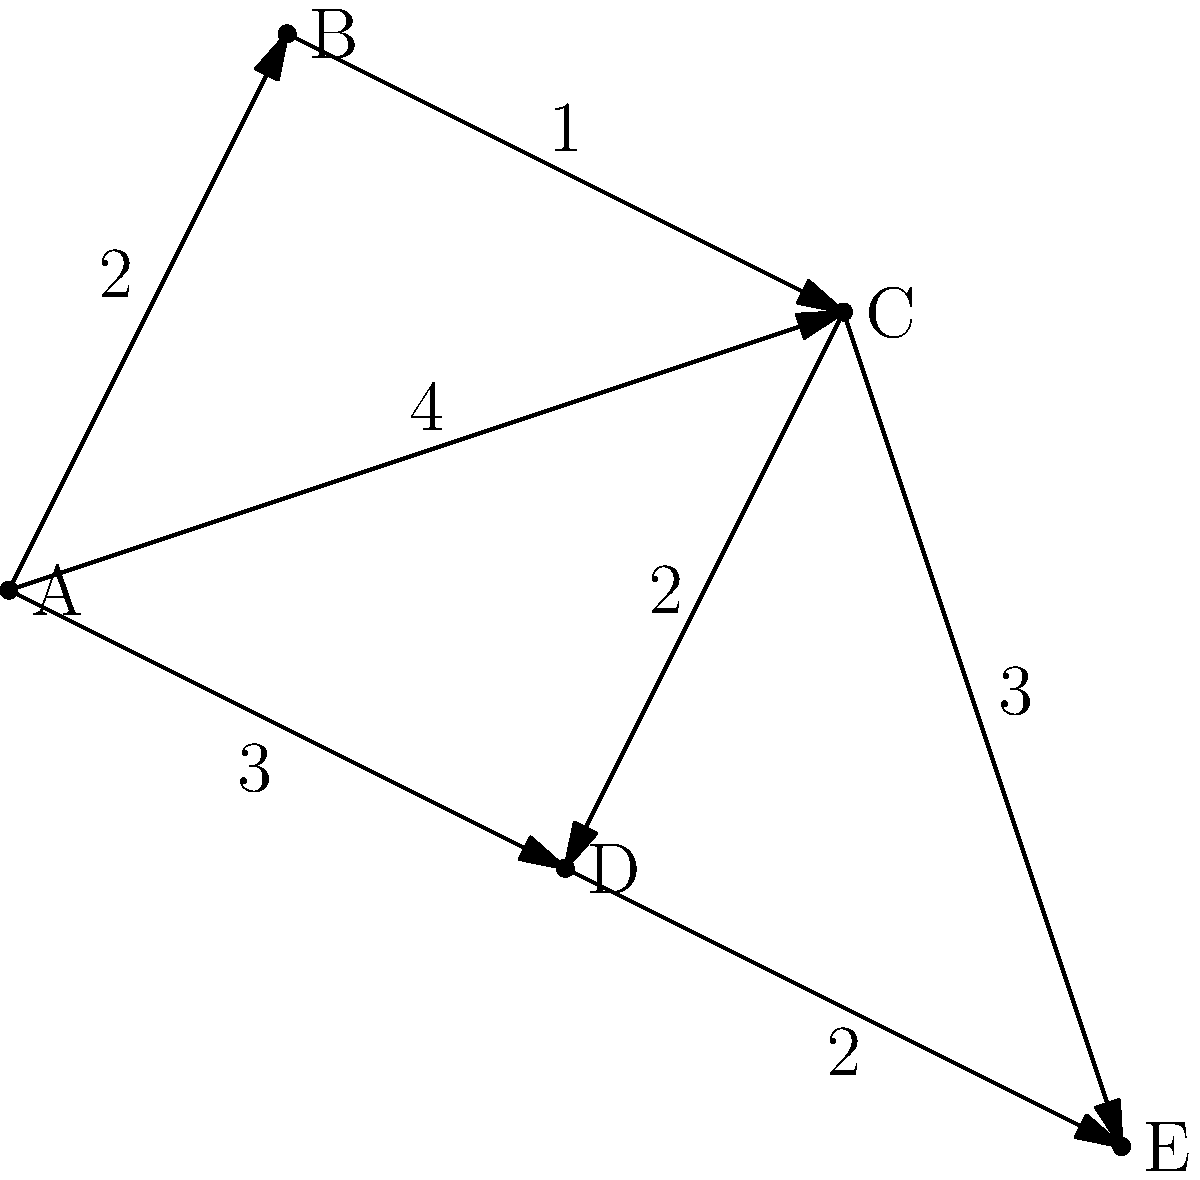Given the city map represented by the network above, where each node represents a location and each edge represents a road with its associated travel time (in minutes), what is the shortest time required for a mobile assistance unit to travel from location A to location E? To find the shortest time from A to E, we need to consider all possible paths and calculate their total times:

1. Path A → B → C → E:
   Time = 2 + 1 + 3 = 6 minutes

2. Path A → C → E:
   Time = 4 + 3 = 7 minutes

3. Path A → D → E:
   Time = 3 + 2 = 5 minutes

4. Path A → C → D → E:
   Time = 4 + 2 + 2 = 8 minutes

5. Path A → D → C → E:
   Time = 3 + 2 + 3 = 8 minutes

Comparing all these paths, we can see that the shortest time is achieved through path A → D → E, which takes 5 minutes.

This problem is an application of the shortest path algorithm in a weighted graph, where the weights represent travel times. In practice, for larger networks, algorithms like Dijkstra's or A* would be used to efficiently compute the shortest path.
Answer: 5 minutes 